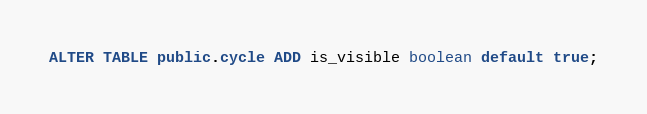Convert code to text. <code><loc_0><loc_0><loc_500><loc_500><_SQL_>ALTER TABLE public.cycle ADD is_visible boolean default true;</code> 